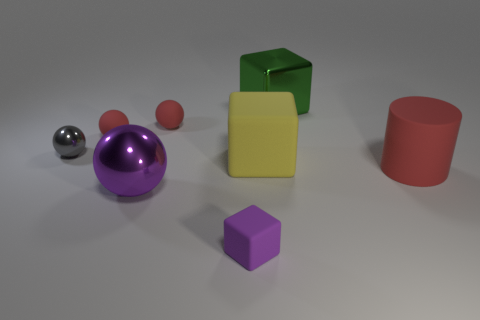What is the size of the rubber block behind the big sphere?
Provide a succinct answer. Large. What shape is the small rubber object that is in front of the big matte object behind the big red cylinder?
Provide a succinct answer. Cube. The small thing that is the same shape as the large green thing is what color?
Ensure brevity in your answer.  Purple. Is the size of the metal thing in front of the yellow rubber cube the same as the purple matte object?
Keep it short and to the point. No. There is a thing that is the same color as the large sphere; what shape is it?
Offer a very short reply. Cube. What number of big yellow things are made of the same material as the tiny block?
Give a very brief answer. 1. There is a red thing that is in front of the large rubber object to the left of the red thing right of the big yellow matte thing; what is its material?
Your answer should be very brief. Rubber. What color is the large shiny thing that is left of the small rubber object that is in front of the large red cylinder?
Offer a very short reply. Purple. What is the color of the metal thing that is the same size as the purple block?
Give a very brief answer. Gray. How many big things are green shiny blocks or gray spheres?
Make the answer very short. 1. 